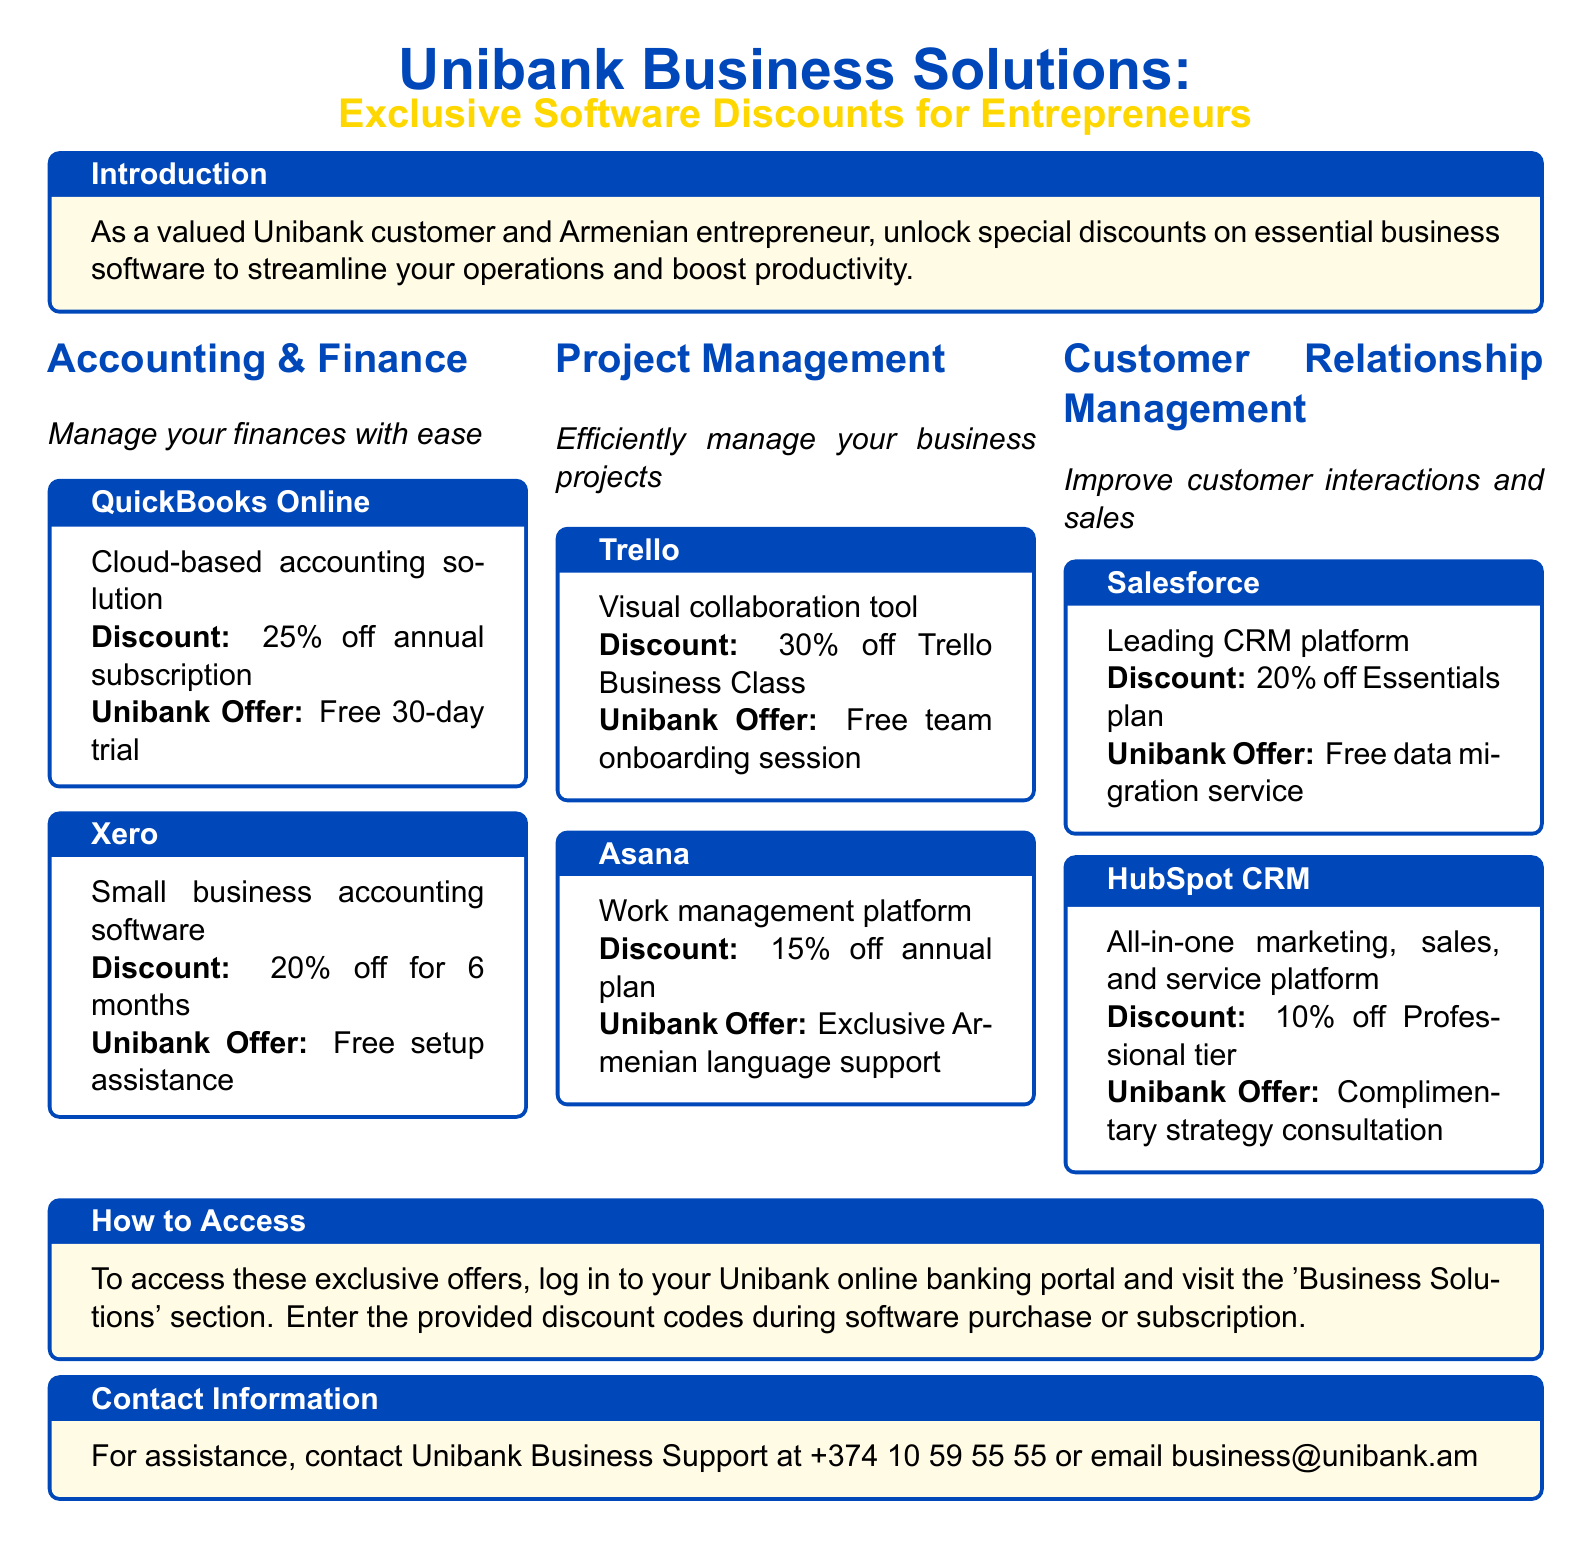What discount is offered for QuickBooks Online? The discount for QuickBooks Online is 25% off annual subscription.
Answer: 25% off annual subscription What additional offer do Unibank customers get with Xero? Unibank customers receive free setup assistance when using Xero.
Answer: Free setup assistance What is the discount percentage for Trello Business Class? Trello Business Class offers a discount of 30% off.
Answer: 30% off What service is offered for free by Salesforce? Salesforce provides a free data migration service for Unibank customers.
Answer: Free data migration service How can Unibank customers access these software discounts? Customers can access the discounts by logging into their Unibank online banking portal and visiting the 'Business Solutions' section.
Answer: Log in to your Unibank online banking portal Which software provides exclusive Armenian language support? Asana offers exclusive Armenian language support for its platform.
Answer: Asana What is the offer associated with HubSpot CRM? The offer associated with HubSpot CRM is a complimentary strategy consultation.
Answer: Complimentary strategy consultation What is the contact number for Unibank Business Support? The contact number for Unibank Business Support is +374 10 59 55 55.
Answer: +374 10 59 55 55 